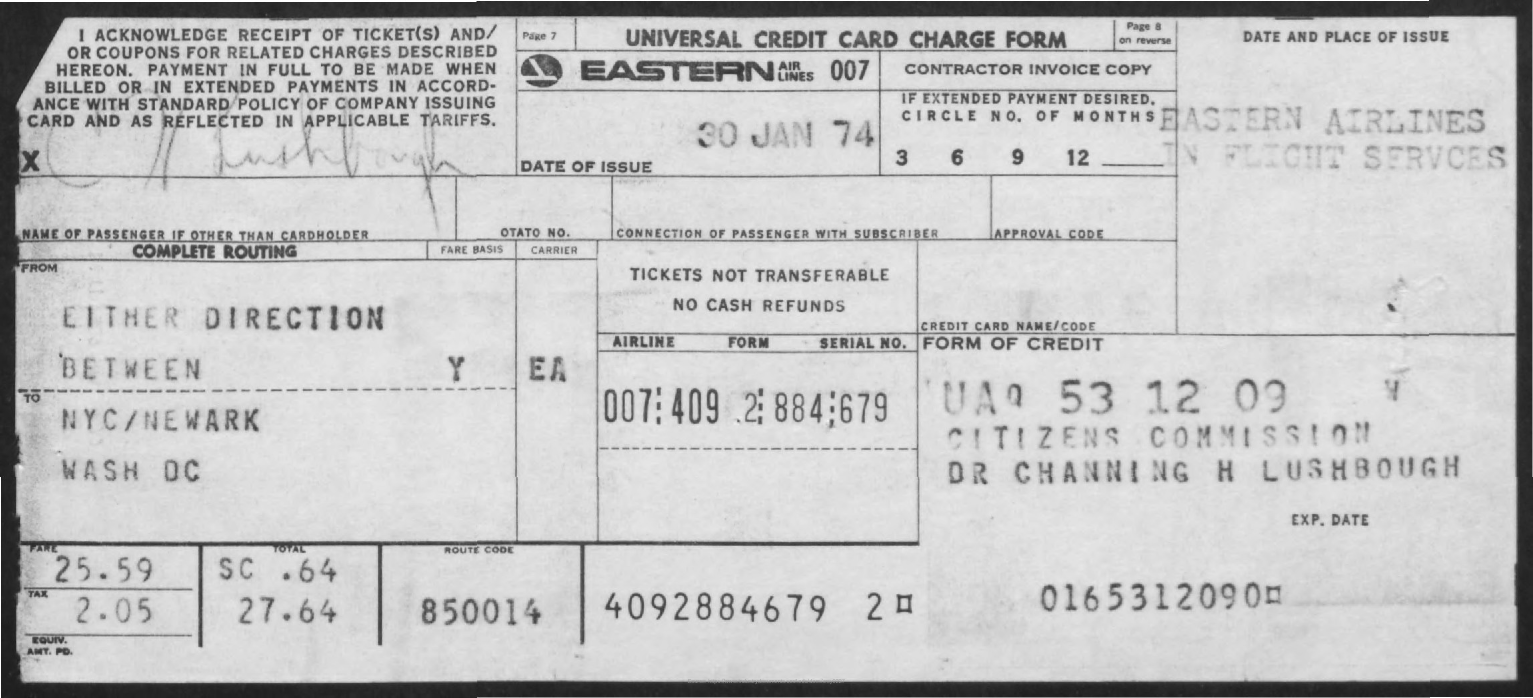Identify some key points in this picture. The Universal Credit Card Charge form is its name. The form was issued on January 30, 1974. 